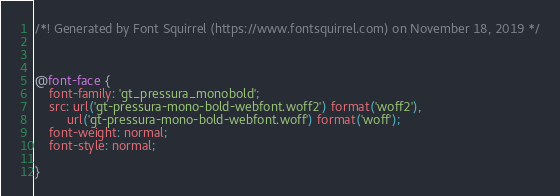<code> <loc_0><loc_0><loc_500><loc_500><_CSS_>/*! Generated by Font Squirrel (https://www.fontsquirrel.com) on November 18, 2019 */



@font-face {
    font-family: 'gt_pressura_monobold';
    src: url('gt-pressura-mono-bold-webfont.woff2') format('woff2'),
         url('gt-pressura-mono-bold-webfont.woff') format('woff');
    font-weight: normal;
    font-style: normal;

}</code> 